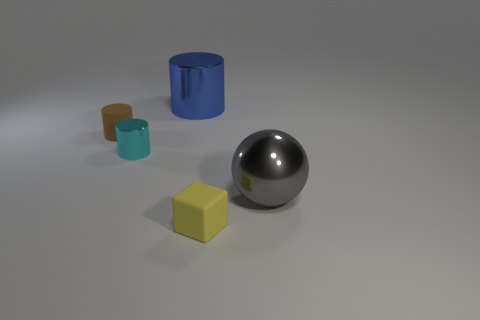Subtract all large blue cylinders. How many cylinders are left? 2 Subtract all brown cylinders. How many cylinders are left? 2 Subtract all spheres. How many objects are left? 4 Add 5 cyan metallic cylinders. How many objects exist? 10 Subtract 0 green cubes. How many objects are left? 5 Subtract all cyan cubes. Subtract all yellow balls. How many cubes are left? 1 Subtract all brown rubber objects. Subtract all cylinders. How many objects are left? 1 Add 1 yellow things. How many yellow things are left? 2 Add 5 tiny cyan shiny cylinders. How many tiny cyan shiny cylinders exist? 6 